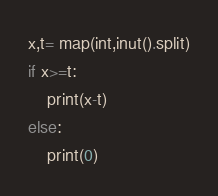Convert code to text. <code><loc_0><loc_0><loc_500><loc_500><_Python_>x,t= map(int,inut().split)
if x>=t:
    print(x-t)
else:
    print(0)</code> 